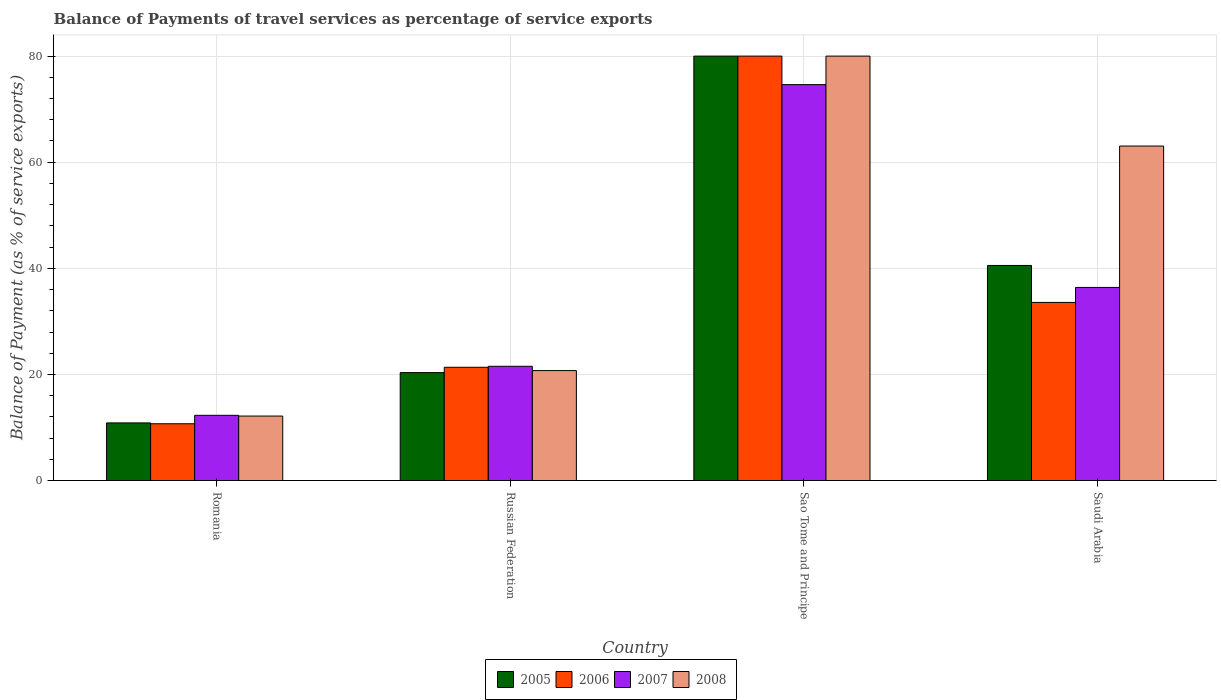How many groups of bars are there?
Keep it short and to the point. 4. Are the number of bars per tick equal to the number of legend labels?
Give a very brief answer. Yes. What is the label of the 2nd group of bars from the left?
Make the answer very short. Russian Federation. In how many cases, is the number of bars for a given country not equal to the number of legend labels?
Give a very brief answer. 0. What is the balance of payments of travel services in 2005 in Romania?
Make the answer very short. 10.87. Across all countries, what is the maximum balance of payments of travel services in 2006?
Provide a short and direct response. 80. Across all countries, what is the minimum balance of payments of travel services in 2008?
Keep it short and to the point. 12.16. In which country was the balance of payments of travel services in 2008 maximum?
Your answer should be compact. Sao Tome and Principe. In which country was the balance of payments of travel services in 2007 minimum?
Offer a terse response. Romania. What is the total balance of payments of travel services in 2005 in the graph?
Your answer should be compact. 151.76. What is the difference between the balance of payments of travel services in 2008 in Russian Federation and that in Saudi Arabia?
Give a very brief answer. -42.32. What is the difference between the balance of payments of travel services in 2006 in Sao Tome and Principe and the balance of payments of travel services in 2005 in Russian Federation?
Your response must be concise. 59.65. What is the average balance of payments of travel services in 2005 per country?
Your response must be concise. 37.94. What is the difference between the balance of payments of travel services of/in 2005 and balance of payments of travel services of/in 2006 in Russian Federation?
Provide a succinct answer. -1.01. In how many countries, is the balance of payments of travel services in 2007 greater than 44 %?
Give a very brief answer. 1. What is the ratio of the balance of payments of travel services in 2005 in Sao Tome and Principe to that in Saudi Arabia?
Provide a succinct answer. 1.97. Is the balance of payments of travel services in 2007 in Romania less than that in Russian Federation?
Offer a very short reply. Yes. Is the difference between the balance of payments of travel services in 2005 in Romania and Saudi Arabia greater than the difference between the balance of payments of travel services in 2006 in Romania and Saudi Arabia?
Your answer should be very brief. No. What is the difference between the highest and the second highest balance of payments of travel services in 2005?
Ensure brevity in your answer.  20.19. What is the difference between the highest and the lowest balance of payments of travel services in 2005?
Your answer should be very brief. 69.13. Is the sum of the balance of payments of travel services in 2006 in Sao Tome and Principe and Saudi Arabia greater than the maximum balance of payments of travel services in 2007 across all countries?
Keep it short and to the point. Yes. Is it the case that in every country, the sum of the balance of payments of travel services in 2007 and balance of payments of travel services in 2006 is greater than the sum of balance of payments of travel services in 2008 and balance of payments of travel services in 2005?
Provide a short and direct response. No. What does the 2nd bar from the left in Saudi Arabia represents?
Provide a short and direct response. 2006. How many bars are there?
Provide a short and direct response. 16. How many countries are there in the graph?
Give a very brief answer. 4. What is the difference between two consecutive major ticks on the Y-axis?
Offer a very short reply. 20. Does the graph contain grids?
Ensure brevity in your answer.  Yes. Where does the legend appear in the graph?
Give a very brief answer. Bottom center. How many legend labels are there?
Your answer should be very brief. 4. What is the title of the graph?
Offer a very short reply. Balance of Payments of travel services as percentage of service exports. What is the label or title of the Y-axis?
Offer a very short reply. Balance of Payment (as % of service exports). What is the Balance of Payment (as % of service exports) in 2005 in Romania?
Your answer should be compact. 10.87. What is the Balance of Payment (as % of service exports) in 2006 in Romania?
Offer a very short reply. 10.71. What is the Balance of Payment (as % of service exports) in 2007 in Romania?
Keep it short and to the point. 12.3. What is the Balance of Payment (as % of service exports) in 2008 in Romania?
Make the answer very short. 12.16. What is the Balance of Payment (as % of service exports) of 2005 in Russian Federation?
Provide a succinct answer. 20.35. What is the Balance of Payment (as % of service exports) of 2006 in Russian Federation?
Your answer should be very brief. 21.35. What is the Balance of Payment (as % of service exports) in 2007 in Russian Federation?
Ensure brevity in your answer.  21.54. What is the Balance of Payment (as % of service exports) of 2008 in Russian Federation?
Your answer should be compact. 20.73. What is the Balance of Payment (as % of service exports) of 2005 in Sao Tome and Principe?
Ensure brevity in your answer.  80. What is the Balance of Payment (as % of service exports) of 2006 in Sao Tome and Principe?
Ensure brevity in your answer.  80. What is the Balance of Payment (as % of service exports) in 2007 in Sao Tome and Principe?
Your answer should be compact. 74.62. What is the Balance of Payment (as % of service exports) in 2008 in Sao Tome and Principe?
Give a very brief answer. 80. What is the Balance of Payment (as % of service exports) of 2005 in Saudi Arabia?
Give a very brief answer. 40.54. What is the Balance of Payment (as % of service exports) in 2006 in Saudi Arabia?
Your answer should be compact. 33.58. What is the Balance of Payment (as % of service exports) of 2007 in Saudi Arabia?
Provide a succinct answer. 36.4. What is the Balance of Payment (as % of service exports) in 2008 in Saudi Arabia?
Provide a short and direct response. 63.05. Across all countries, what is the maximum Balance of Payment (as % of service exports) of 2005?
Your answer should be very brief. 80. Across all countries, what is the maximum Balance of Payment (as % of service exports) of 2006?
Make the answer very short. 80. Across all countries, what is the maximum Balance of Payment (as % of service exports) of 2007?
Offer a very short reply. 74.62. Across all countries, what is the maximum Balance of Payment (as % of service exports) of 2008?
Give a very brief answer. 80. Across all countries, what is the minimum Balance of Payment (as % of service exports) of 2005?
Provide a short and direct response. 10.87. Across all countries, what is the minimum Balance of Payment (as % of service exports) in 2006?
Make the answer very short. 10.71. Across all countries, what is the minimum Balance of Payment (as % of service exports) in 2007?
Your answer should be very brief. 12.3. Across all countries, what is the minimum Balance of Payment (as % of service exports) in 2008?
Your answer should be very brief. 12.16. What is the total Balance of Payment (as % of service exports) of 2005 in the graph?
Keep it short and to the point. 151.76. What is the total Balance of Payment (as % of service exports) in 2006 in the graph?
Provide a short and direct response. 145.64. What is the total Balance of Payment (as % of service exports) in 2007 in the graph?
Your answer should be compact. 144.87. What is the total Balance of Payment (as % of service exports) of 2008 in the graph?
Give a very brief answer. 175.93. What is the difference between the Balance of Payment (as % of service exports) in 2005 in Romania and that in Russian Federation?
Your answer should be very brief. -9.48. What is the difference between the Balance of Payment (as % of service exports) of 2006 in Romania and that in Russian Federation?
Provide a succinct answer. -10.65. What is the difference between the Balance of Payment (as % of service exports) of 2007 in Romania and that in Russian Federation?
Your answer should be very brief. -9.24. What is the difference between the Balance of Payment (as % of service exports) of 2008 in Romania and that in Russian Federation?
Give a very brief answer. -8.57. What is the difference between the Balance of Payment (as % of service exports) of 2005 in Romania and that in Sao Tome and Principe?
Ensure brevity in your answer.  -69.13. What is the difference between the Balance of Payment (as % of service exports) in 2006 in Romania and that in Sao Tome and Principe?
Your answer should be compact. -69.29. What is the difference between the Balance of Payment (as % of service exports) in 2007 in Romania and that in Sao Tome and Principe?
Ensure brevity in your answer.  -62.33. What is the difference between the Balance of Payment (as % of service exports) of 2008 in Romania and that in Sao Tome and Principe?
Offer a terse response. -67.84. What is the difference between the Balance of Payment (as % of service exports) in 2005 in Romania and that in Saudi Arabia?
Make the answer very short. -29.67. What is the difference between the Balance of Payment (as % of service exports) of 2006 in Romania and that in Saudi Arabia?
Your answer should be compact. -22.87. What is the difference between the Balance of Payment (as % of service exports) of 2007 in Romania and that in Saudi Arabia?
Your response must be concise. -24.1. What is the difference between the Balance of Payment (as % of service exports) of 2008 in Romania and that in Saudi Arabia?
Provide a short and direct response. -50.89. What is the difference between the Balance of Payment (as % of service exports) of 2005 in Russian Federation and that in Sao Tome and Principe?
Your answer should be compact. -59.65. What is the difference between the Balance of Payment (as % of service exports) in 2006 in Russian Federation and that in Sao Tome and Principe?
Your response must be concise. -58.64. What is the difference between the Balance of Payment (as % of service exports) in 2007 in Russian Federation and that in Sao Tome and Principe?
Make the answer very short. -53.09. What is the difference between the Balance of Payment (as % of service exports) of 2008 in Russian Federation and that in Sao Tome and Principe?
Give a very brief answer. -59.27. What is the difference between the Balance of Payment (as % of service exports) in 2005 in Russian Federation and that in Saudi Arabia?
Keep it short and to the point. -20.19. What is the difference between the Balance of Payment (as % of service exports) of 2006 in Russian Federation and that in Saudi Arabia?
Make the answer very short. -12.22. What is the difference between the Balance of Payment (as % of service exports) in 2007 in Russian Federation and that in Saudi Arabia?
Keep it short and to the point. -14.86. What is the difference between the Balance of Payment (as % of service exports) in 2008 in Russian Federation and that in Saudi Arabia?
Your answer should be very brief. -42.32. What is the difference between the Balance of Payment (as % of service exports) of 2005 in Sao Tome and Principe and that in Saudi Arabia?
Ensure brevity in your answer.  39.46. What is the difference between the Balance of Payment (as % of service exports) of 2006 in Sao Tome and Principe and that in Saudi Arabia?
Give a very brief answer. 46.42. What is the difference between the Balance of Payment (as % of service exports) in 2007 in Sao Tome and Principe and that in Saudi Arabia?
Ensure brevity in your answer.  38.22. What is the difference between the Balance of Payment (as % of service exports) of 2008 in Sao Tome and Principe and that in Saudi Arabia?
Offer a very short reply. 16.95. What is the difference between the Balance of Payment (as % of service exports) in 2005 in Romania and the Balance of Payment (as % of service exports) in 2006 in Russian Federation?
Ensure brevity in your answer.  -10.49. What is the difference between the Balance of Payment (as % of service exports) of 2005 in Romania and the Balance of Payment (as % of service exports) of 2007 in Russian Federation?
Your response must be concise. -10.67. What is the difference between the Balance of Payment (as % of service exports) in 2005 in Romania and the Balance of Payment (as % of service exports) in 2008 in Russian Federation?
Your response must be concise. -9.86. What is the difference between the Balance of Payment (as % of service exports) of 2006 in Romania and the Balance of Payment (as % of service exports) of 2007 in Russian Federation?
Provide a succinct answer. -10.83. What is the difference between the Balance of Payment (as % of service exports) of 2006 in Romania and the Balance of Payment (as % of service exports) of 2008 in Russian Federation?
Offer a terse response. -10.02. What is the difference between the Balance of Payment (as % of service exports) in 2007 in Romania and the Balance of Payment (as % of service exports) in 2008 in Russian Federation?
Give a very brief answer. -8.43. What is the difference between the Balance of Payment (as % of service exports) of 2005 in Romania and the Balance of Payment (as % of service exports) of 2006 in Sao Tome and Principe?
Your answer should be very brief. -69.13. What is the difference between the Balance of Payment (as % of service exports) in 2005 in Romania and the Balance of Payment (as % of service exports) in 2007 in Sao Tome and Principe?
Offer a very short reply. -63.76. What is the difference between the Balance of Payment (as % of service exports) of 2005 in Romania and the Balance of Payment (as % of service exports) of 2008 in Sao Tome and Principe?
Offer a terse response. -69.13. What is the difference between the Balance of Payment (as % of service exports) of 2006 in Romania and the Balance of Payment (as % of service exports) of 2007 in Sao Tome and Principe?
Keep it short and to the point. -63.92. What is the difference between the Balance of Payment (as % of service exports) in 2006 in Romania and the Balance of Payment (as % of service exports) in 2008 in Sao Tome and Principe?
Offer a very short reply. -69.29. What is the difference between the Balance of Payment (as % of service exports) in 2007 in Romania and the Balance of Payment (as % of service exports) in 2008 in Sao Tome and Principe?
Your response must be concise. -67.7. What is the difference between the Balance of Payment (as % of service exports) in 2005 in Romania and the Balance of Payment (as % of service exports) in 2006 in Saudi Arabia?
Give a very brief answer. -22.71. What is the difference between the Balance of Payment (as % of service exports) in 2005 in Romania and the Balance of Payment (as % of service exports) in 2007 in Saudi Arabia?
Ensure brevity in your answer.  -25.53. What is the difference between the Balance of Payment (as % of service exports) in 2005 in Romania and the Balance of Payment (as % of service exports) in 2008 in Saudi Arabia?
Ensure brevity in your answer.  -52.18. What is the difference between the Balance of Payment (as % of service exports) of 2006 in Romania and the Balance of Payment (as % of service exports) of 2007 in Saudi Arabia?
Your answer should be compact. -25.7. What is the difference between the Balance of Payment (as % of service exports) in 2006 in Romania and the Balance of Payment (as % of service exports) in 2008 in Saudi Arabia?
Offer a very short reply. -52.34. What is the difference between the Balance of Payment (as % of service exports) of 2007 in Romania and the Balance of Payment (as % of service exports) of 2008 in Saudi Arabia?
Provide a succinct answer. -50.75. What is the difference between the Balance of Payment (as % of service exports) in 2005 in Russian Federation and the Balance of Payment (as % of service exports) in 2006 in Sao Tome and Principe?
Your answer should be very brief. -59.65. What is the difference between the Balance of Payment (as % of service exports) of 2005 in Russian Federation and the Balance of Payment (as % of service exports) of 2007 in Sao Tome and Principe?
Make the answer very short. -54.28. What is the difference between the Balance of Payment (as % of service exports) in 2005 in Russian Federation and the Balance of Payment (as % of service exports) in 2008 in Sao Tome and Principe?
Make the answer very short. -59.65. What is the difference between the Balance of Payment (as % of service exports) in 2006 in Russian Federation and the Balance of Payment (as % of service exports) in 2007 in Sao Tome and Principe?
Offer a terse response. -53.27. What is the difference between the Balance of Payment (as % of service exports) in 2006 in Russian Federation and the Balance of Payment (as % of service exports) in 2008 in Sao Tome and Principe?
Make the answer very short. -58.64. What is the difference between the Balance of Payment (as % of service exports) in 2007 in Russian Federation and the Balance of Payment (as % of service exports) in 2008 in Sao Tome and Principe?
Give a very brief answer. -58.46. What is the difference between the Balance of Payment (as % of service exports) of 2005 in Russian Federation and the Balance of Payment (as % of service exports) of 2006 in Saudi Arabia?
Keep it short and to the point. -13.23. What is the difference between the Balance of Payment (as % of service exports) in 2005 in Russian Federation and the Balance of Payment (as % of service exports) in 2007 in Saudi Arabia?
Keep it short and to the point. -16.05. What is the difference between the Balance of Payment (as % of service exports) of 2005 in Russian Federation and the Balance of Payment (as % of service exports) of 2008 in Saudi Arabia?
Your answer should be compact. -42.7. What is the difference between the Balance of Payment (as % of service exports) in 2006 in Russian Federation and the Balance of Payment (as % of service exports) in 2007 in Saudi Arabia?
Make the answer very short. -15.05. What is the difference between the Balance of Payment (as % of service exports) of 2006 in Russian Federation and the Balance of Payment (as % of service exports) of 2008 in Saudi Arabia?
Offer a terse response. -41.69. What is the difference between the Balance of Payment (as % of service exports) in 2007 in Russian Federation and the Balance of Payment (as % of service exports) in 2008 in Saudi Arabia?
Ensure brevity in your answer.  -41.51. What is the difference between the Balance of Payment (as % of service exports) in 2005 in Sao Tome and Principe and the Balance of Payment (as % of service exports) in 2006 in Saudi Arabia?
Offer a very short reply. 46.42. What is the difference between the Balance of Payment (as % of service exports) of 2005 in Sao Tome and Principe and the Balance of Payment (as % of service exports) of 2007 in Saudi Arabia?
Ensure brevity in your answer.  43.6. What is the difference between the Balance of Payment (as % of service exports) in 2005 in Sao Tome and Principe and the Balance of Payment (as % of service exports) in 2008 in Saudi Arabia?
Your answer should be very brief. 16.95. What is the difference between the Balance of Payment (as % of service exports) of 2006 in Sao Tome and Principe and the Balance of Payment (as % of service exports) of 2007 in Saudi Arabia?
Provide a succinct answer. 43.6. What is the difference between the Balance of Payment (as % of service exports) in 2006 in Sao Tome and Principe and the Balance of Payment (as % of service exports) in 2008 in Saudi Arabia?
Your answer should be compact. 16.95. What is the difference between the Balance of Payment (as % of service exports) in 2007 in Sao Tome and Principe and the Balance of Payment (as % of service exports) in 2008 in Saudi Arabia?
Ensure brevity in your answer.  11.58. What is the average Balance of Payment (as % of service exports) in 2005 per country?
Your response must be concise. 37.94. What is the average Balance of Payment (as % of service exports) in 2006 per country?
Ensure brevity in your answer.  36.41. What is the average Balance of Payment (as % of service exports) in 2007 per country?
Your answer should be very brief. 36.22. What is the average Balance of Payment (as % of service exports) of 2008 per country?
Offer a terse response. 43.98. What is the difference between the Balance of Payment (as % of service exports) in 2005 and Balance of Payment (as % of service exports) in 2006 in Romania?
Provide a succinct answer. 0.16. What is the difference between the Balance of Payment (as % of service exports) in 2005 and Balance of Payment (as % of service exports) in 2007 in Romania?
Ensure brevity in your answer.  -1.43. What is the difference between the Balance of Payment (as % of service exports) in 2005 and Balance of Payment (as % of service exports) in 2008 in Romania?
Your response must be concise. -1.29. What is the difference between the Balance of Payment (as % of service exports) of 2006 and Balance of Payment (as % of service exports) of 2007 in Romania?
Provide a short and direct response. -1.59. What is the difference between the Balance of Payment (as % of service exports) of 2006 and Balance of Payment (as % of service exports) of 2008 in Romania?
Your answer should be compact. -1.45. What is the difference between the Balance of Payment (as % of service exports) in 2007 and Balance of Payment (as % of service exports) in 2008 in Romania?
Provide a short and direct response. 0.14. What is the difference between the Balance of Payment (as % of service exports) of 2005 and Balance of Payment (as % of service exports) of 2006 in Russian Federation?
Offer a terse response. -1.01. What is the difference between the Balance of Payment (as % of service exports) in 2005 and Balance of Payment (as % of service exports) in 2007 in Russian Federation?
Provide a short and direct response. -1.19. What is the difference between the Balance of Payment (as % of service exports) of 2005 and Balance of Payment (as % of service exports) of 2008 in Russian Federation?
Provide a succinct answer. -0.38. What is the difference between the Balance of Payment (as % of service exports) in 2006 and Balance of Payment (as % of service exports) in 2007 in Russian Federation?
Ensure brevity in your answer.  -0.18. What is the difference between the Balance of Payment (as % of service exports) of 2006 and Balance of Payment (as % of service exports) of 2008 in Russian Federation?
Keep it short and to the point. 0.63. What is the difference between the Balance of Payment (as % of service exports) in 2007 and Balance of Payment (as % of service exports) in 2008 in Russian Federation?
Your response must be concise. 0.81. What is the difference between the Balance of Payment (as % of service exports) in 2005 and Balance of Payment (as % of service exports) in 2006 in Sao Tome and Principe?
Provide a short and direct response. -0. What is the difference between the Balance of Payment (as % of service exports) of 2005 and Balance of Payment (as % of service exports) of 2007 in Sao Tome and Principe?
Your answer should be compact. 5.37. What is the difference between the Balance of Payment (as % of service exports) in 2005 and Balance of Payment (as % of service exports) in 2008 in Sao Tome and Principe?
Offer a terse response. -0. What is the difference between the Balance of Payment (as % of service exports) in 2006 and Balance of Payment (as % of service exports) in 2007 in Sao Tome and Principe?
Make the answer very short. 5.37. What is the difference between the Balance of Payment (as % of service exports) in 2007 and Balance of Payment (as % of service exports) in 2008 in Sao Tome and Principe?
Ensure brevity in your answer.  -5.37. What is the difference between the Balance of Payment (as % of service exports) in 2005 and Balance of Payment (as % of service exports) in 2006 in Saudi Arabia?
Give a very brief answer. 6.96. What is the difference between the Balance of Payment (as % of service exports) in 2005 and Balance of Payment (as % of service exports) in 2007 in Saudi Arabia?
Offer a terse response. 4.14. What is the difference between the Balance of Payment (as % of service exports) of 2005 and Balance of Payment (as % of service exports) of 2008 in Saudi Arabia?
Keep it short and to the point. -22.51. What is the difference between the Balance of Payment (as % of service exports) of 2006 and Balance of Payment (as % of service exports) of 2007 in Saudi Arabia?
Ensure brevity in your answer.  -2.82. What is the difference between the Balance of Payment (as % of service exports) of 2006 and Balance of Payment (as % of service exports) of 2008 in Saudi Arabia?
Make the answer very short. -29.47. What is the difference between the Balance of Payment (as % of service exports) in 2007 and Balance of Payment (as % of service exports) in 2008 in Saudi Arabia?
Keep it short and to the point. -26.65. What is the ratio of the Balance of Payment (as % of service exports) in 2005 in Romania to that in Russian Federation?
Offer a very short reply. 0.53. What is the ratio of the Balance of Payment (as % of service exports) in 2006 in Romania to that in Russian Federation?
Your response must be concise. 0.5. What is the ratio of the Balance of Payment (as % of service exports) in 2007 in Romania to that in Russian Federation?
Keep it short and to the point. 0.57. What is the ratio of the Balance of Payment (as % of service exports) of 2008 in Romania to that in Russian Federation?
Offer a very short reply. 0.59. What is the ratio of the Balance of Payment (as % of service exports) of 2005 in Romania to that in Sao Tome and Principe?
Give a very brief answer. 0.14. What is the ratio of the Balance of Payment (as % of service exports) in 2006 in Romania to that in Sao Tome and Principe?
Make the answer very short. 0.13. What is the ratio of the Balance of Payment (as % of service exports) in 2007 in Romania to that in Sao Tome and Principe?
Offer a very short reply. 0.16. What is the ratio of the Balance of Payment (as % of service exports) of 2008 in Romania to that in Sao Tome and Principe?
Offer a very short reply. 0.15. What is the ratio of the Balance of Payment (as % of service exports) of 2005 in Romania to that in Saudi Arabia?
Provide a succinct answer. 0.27. What is the ratio of the Balance of Payment (as % of service exports) of 2006 in Romania to that in Saudi Arabia?
Give a very brief answer. 0.32. What is the ratio of the Balance of Payment (as % of service exports) of 2007 in Romania to that in Saudi Arabia?
Make the answer very short. 0.34. What is the ratio of the Balance of Payment (as % of service exports) in 2008 in Romania to that in Saudi Arabia?
Keep it short and to the point. 0.19. What is the ratio of the Balance of Payment (as % of service exports) of 2005 in Russian Federation to that in Sao Tome and Principe?
Keep it short and to the point. 0.25. What is the ratio of the Balance of Payment (as % of service exports) of 2006 in Russian Federation to that in Sao Tome and Principe?
Give a very brief answer. 0.27. What is the ratio of the Balance of Payment (as % of service exports) of 2007 in Russian Federation to that in Sao Tome and Principe?
Provide a succinct answer. 0.29. What is the ratio of the Balance of Payment (as % of service exports) in 2008 in Russian Federation to that in Sao Tome and Principe?
Ensure brevity in your answer.  0.26. What is the ratio of the Balance of Payment (as % of service exports) in 2005 in Russian Federation to that in Saudi Arabia?
Keep it short and to the point. 0.5. What is the ratio of the Balance of Payment (as % of service exports) of 2006 in Russian Federation to that in Saudi Arabia?
Your response must be concise. 0.64. What is the ratio of the Balance of Payment (as % of service exports) of 2007 in Russian Federation to that in Saudi Arabia?
Offer a terse response. 0.59. What is the ratio of the Balance of Payment (as % of service exports) of 2008 in Russian Federation to that in Saudi Arabia?
Offer a very short reply. 0.33. What is the ratio of the Balance of Payment (as % of service exports) in 2005 in Sao Tome and Principe to that in Saudi Arabia?
Your answer should be compact. 1.97. What is the ratio of the Balance of Payment (as % of service exports) of 2006 in Sao Tome and Principe to that in Saudi Arabia?
Offer a very short reply. 2.38. What is the ratio of the Balance of Payment (as % of service exports) in 2007 in Sao Tome and Principe to that in Saudi Arabia?
Offer a terse response. 2.05. What is the ratio of the Balance of Payment (as % of service exports) of 2008 in Sao Tome and Principe to that in Saudi Arabia?
Your response must be concise. 1.27. What is the difference between the highest and the second highest Balance of Payment (as % of service exports) in 2005?
Provide a short and direct response. 39.46. What is the difference between the highest and the second highest Balance of Payment (as % of service exports) in 2006?
Keep it short and to the point. 46.42. What is the difference between the highest and the second highest Balance of Payment (as % of service exports) of 2007?
Ensure brevity in your answer.  38.22. What is the difference between the highest and the second highest Balance of Payment (as % of service exports) in 2008?
Ensure brevity in your answer.  16.95. What is the difference between the highest and the lowest Balance of Payment (as % of service exports) of 2005?
Your response must be concise. 69.13. What is the difference between the highest and the lowest Balance of Payment (as % of service exports) in 2006?
Make the answer very short. 69.29. What is the difference between the highest and the lowest Balance of Payment (as % of service exports) in 2007?
Give a very brief answer. 62.33. What is the difference between the highest and the lowest Balance of Payment (as % of service exports) in 2008?
Give a very brief answer. 67.84. 